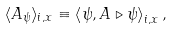Convert formula to latex. <formula><loc_0><loc_0><loc_500><loc_500>\langle A _ { \psi } \rangle _ { i , x } \equiv \left \langle \psi , A \triangleright \psi \right \rangle _ { i , x } ,</formula> 